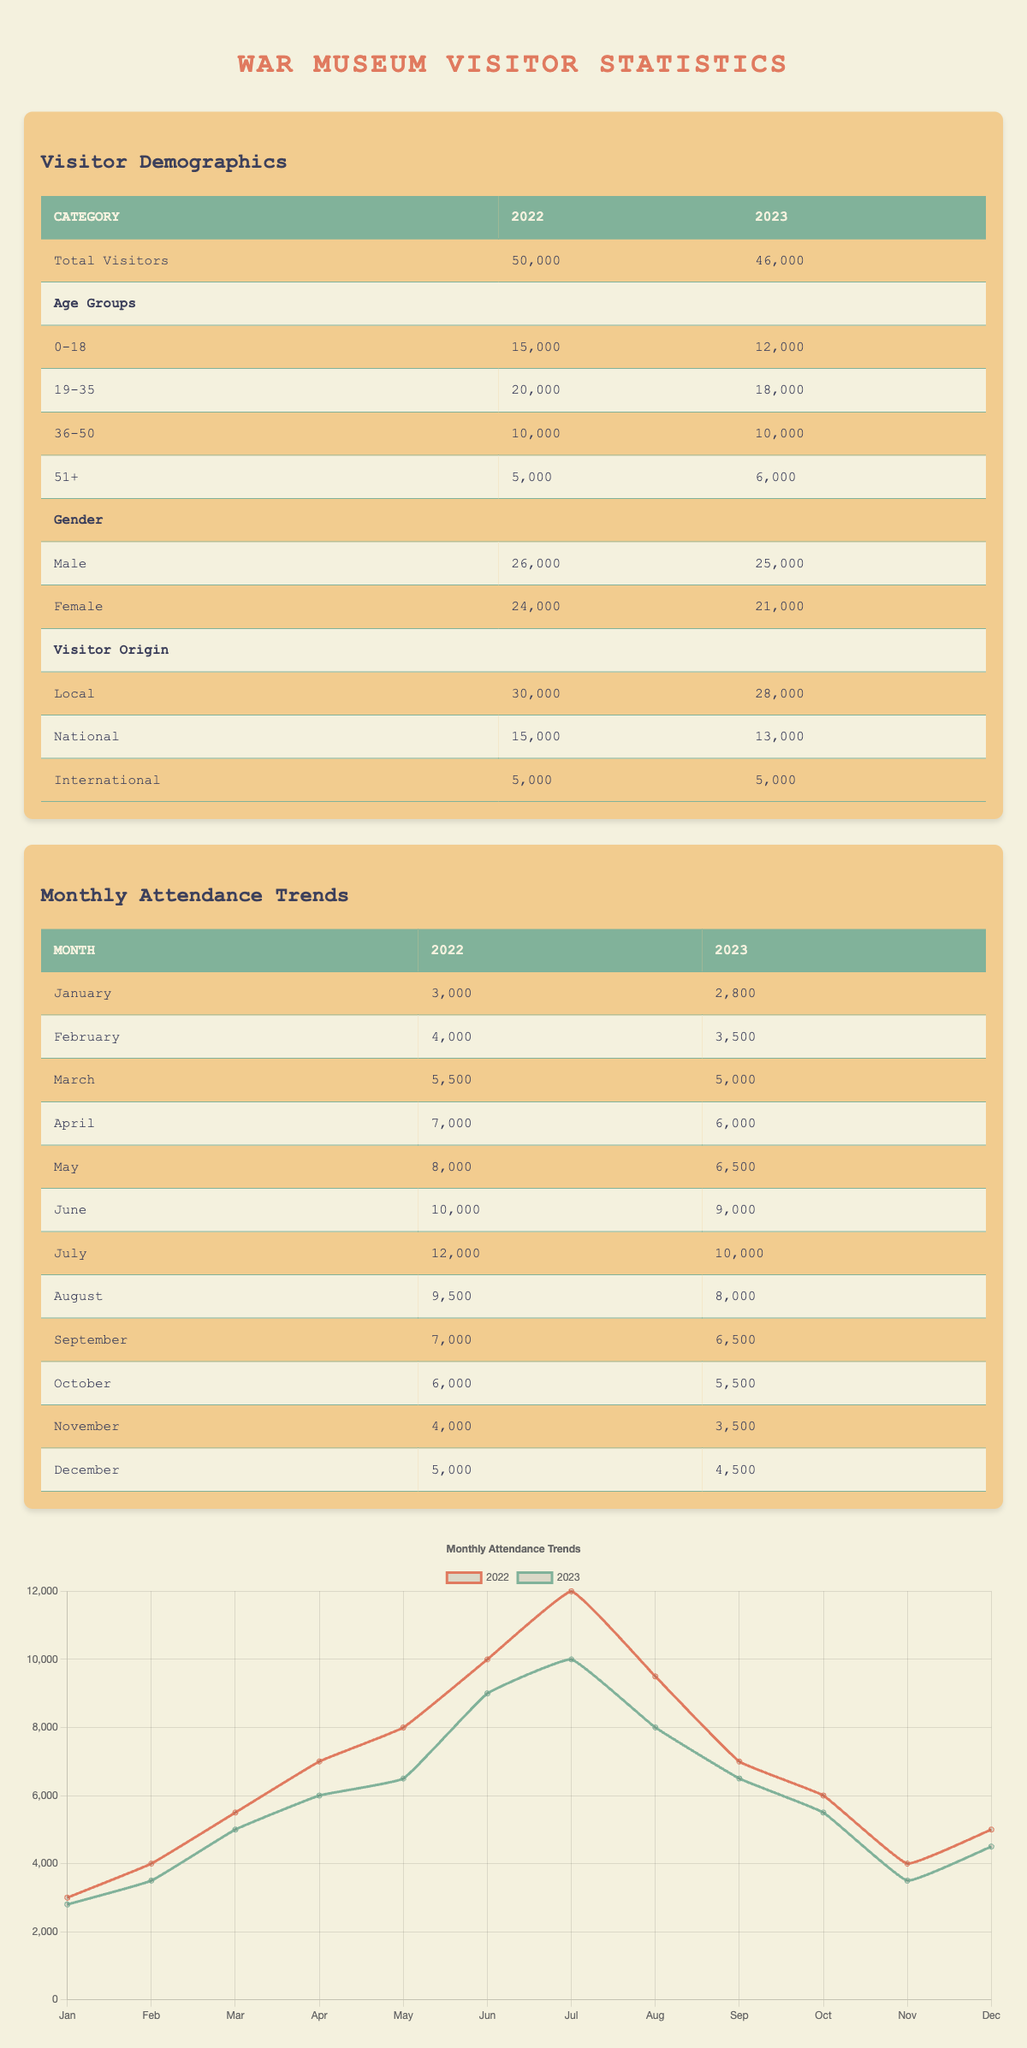What was the total number of visitors to the war museum in 2022? The table lists the total number of visitors for 2022, which is clearly stated as 50,000.
Answer: 50,000 How many visitors came from local origins in 2023? The data shows that for the year 2023, the number of visitors from local origins is 28,000.
Answer: 28,000 What is the percentage decrease in total visitors from 2022 to 2023? To find the percentage decrease, we subtract the 2023 total visitors from the 2022 total: 50,000 - 46,000 = 4,000. Next, we divide the decrease by the original number and multiply by 100: (4,000 / 50,000) × 100 = 8%.
Answer: 8% Which age group saw the largest increase in the number of visitors from 2022 to 2023? Comparing the age groups, the 51+ category increased from 5,000 in 2022 to 6,000 in 2023, showing an increase of 1,000. Other age groups either decreased or remained the same, indicating that 51+ is the only one with an increase.
Answer: 51+ Is there a higher number of male or female visitors in 2023? For 2023, male visitors numbered 25,000, while female visitors numbered 21,000. Since 25,000 is greater than 21,000, there are more male visitors.
Answer: Yes What is the total number of visitors aged 0-50 in 2022? The total number of visitors aged 0-50 includes those from the 0-18, 19-35, and 36-50 age groups. Adding these numbers gives: 15,000 + 20,000 + 10,000 = 45,000.
Answer: 45,000 How much did attendance drop in July from 2022 to 2023? In July, attendance was 12,000 in 2022 and dropped to 10,000 in 2023. The difference is 12,000 - 10,000 = 2,000.
Answer: 2,000 Did the international visitors' count remain the same from 2022 to 2023? The data shows that international visitors remained at 5,000 in both years, indicating that the count did not change.
Answer: Yes What is the average attendance for the months of January to March in 2023? To find the average, add the attendance numbers for January (2,800), February (3,500), and March (5,000): 2,800 + 3,500 + 5,000 = 11,300. Then divide by 3: 11,300 / 3 = 3,766.67.
Answer: 3,766.67 